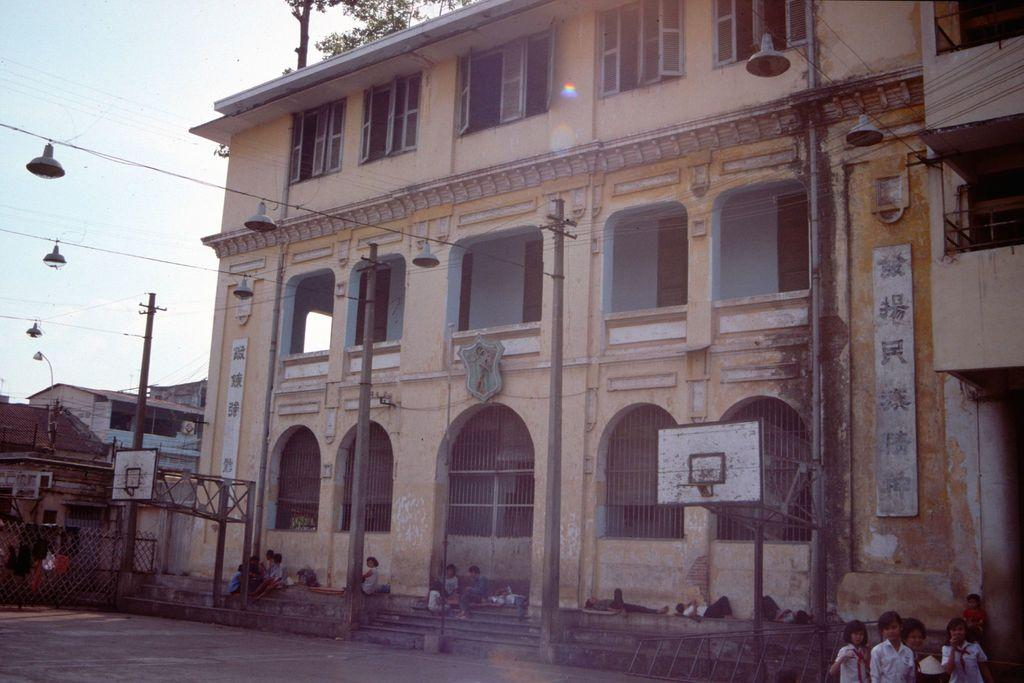What is the position of the children in the image? Some children are standing, some are sitting, and some are lying in the image. What can be seen behind the children? There are poles, buildings, and trees behind the children. What is visible in the top left corner of the image? The sky is visible in the top left corner of the image. What is the texture of the flag in the image? There is no flag present in the image, so it is not possible to determine its texture. 